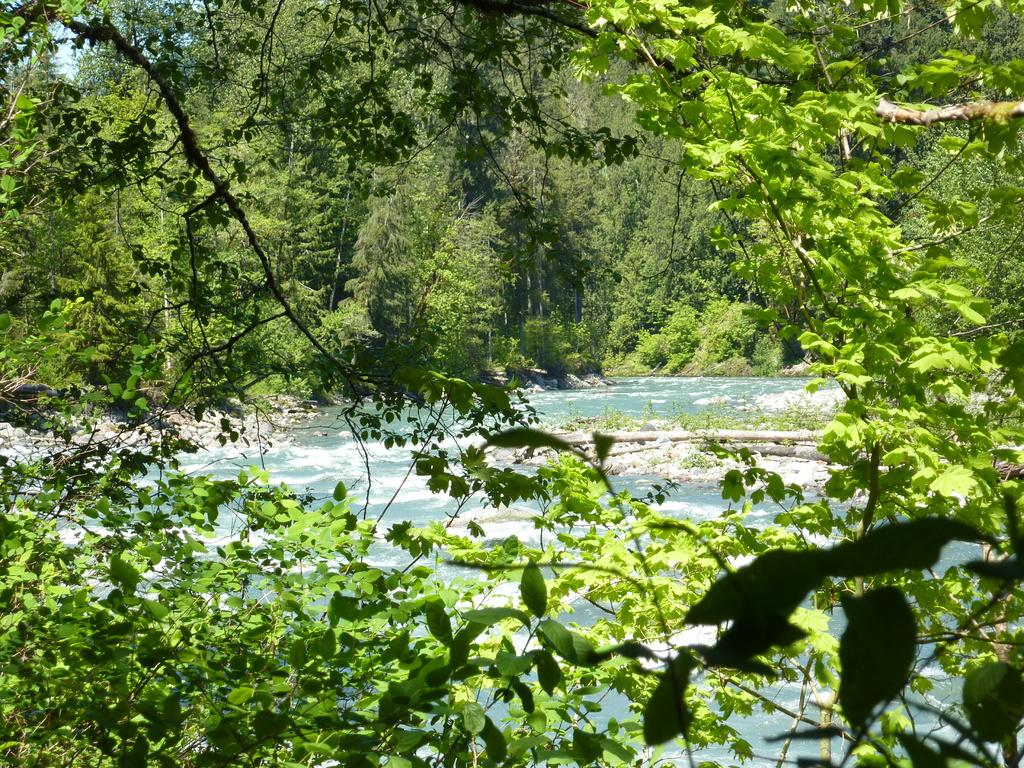What is the primary element visible in the image? There is water in the image. What type of vegetation can be seen in the image? There are trees in the image. What is visible in the background of the image? The sky is visible behind the trees in the image. How many screws can be seen holding the cactus in the image? There is no cactus or screws present in the image. 